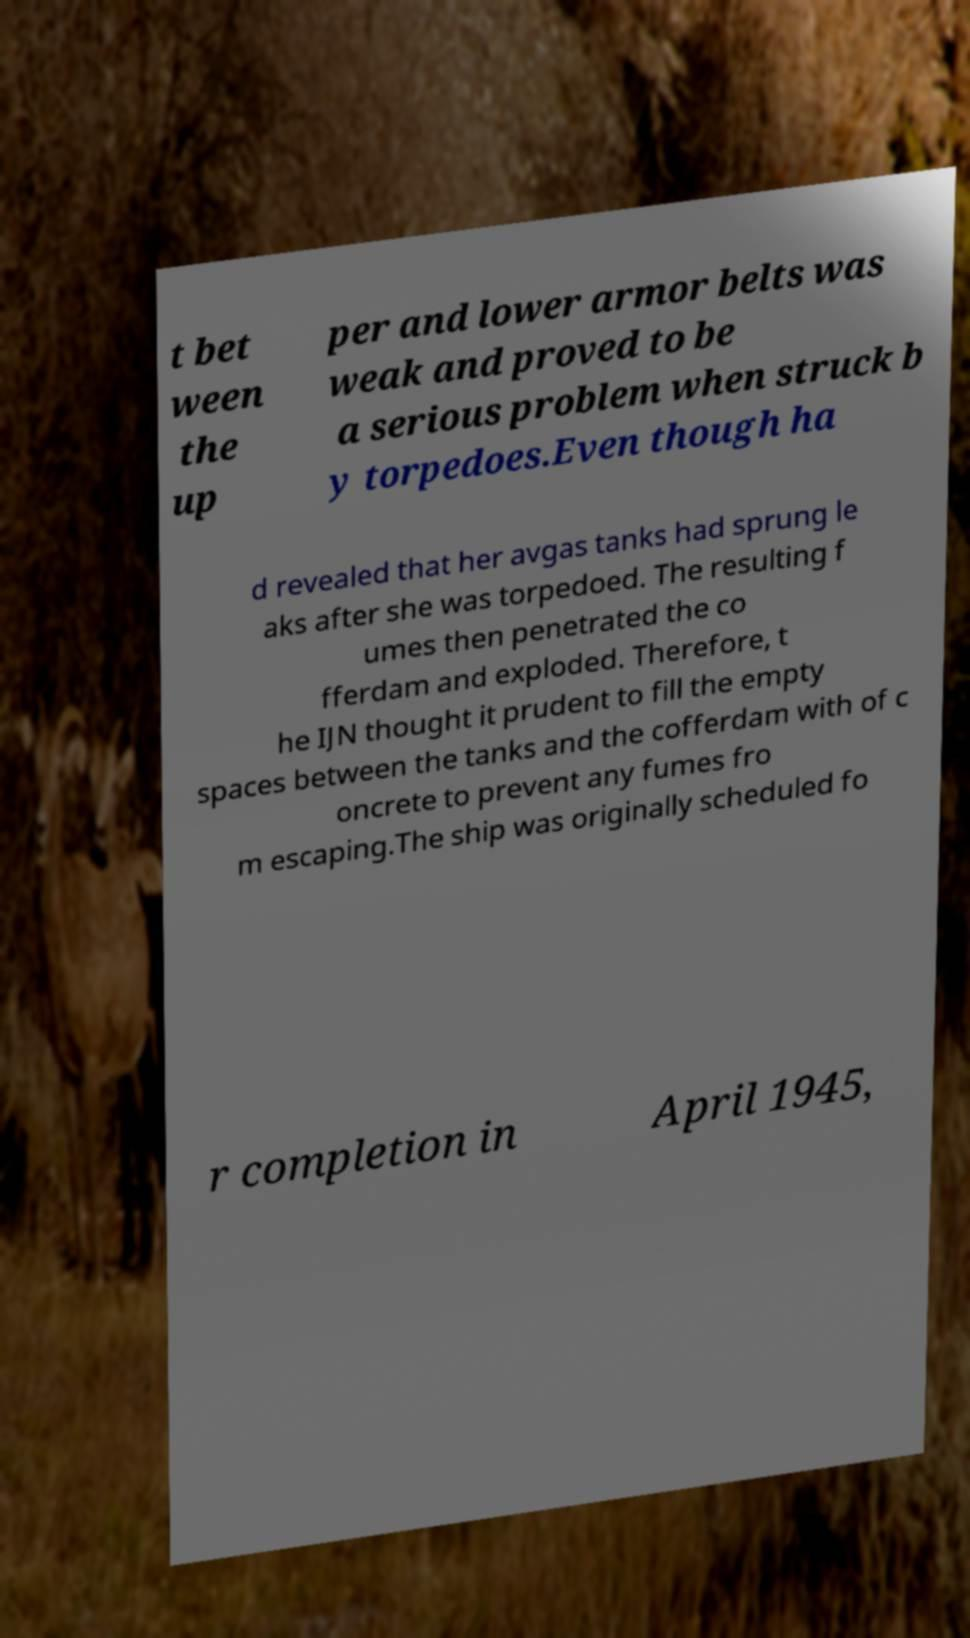Could you assist in decoding the text presented in this image and type it out clearly? t bet ween the up per and lower armor belts was weak and proved to be a serious problem when struck b y torpedoes.Even though ha d revealed that her avgas tanks had sprung le aks after she was torpedoed. The resulting f umes then penetrated the co fferdam and exploded. Therefore, t he IJN thought it prudent to fill the empty spaces between the tanks and the cofferdam with of c oncrete to prevent any fumes fro m escaping.The ship was originally scheduled fo r completion in April 1945, 